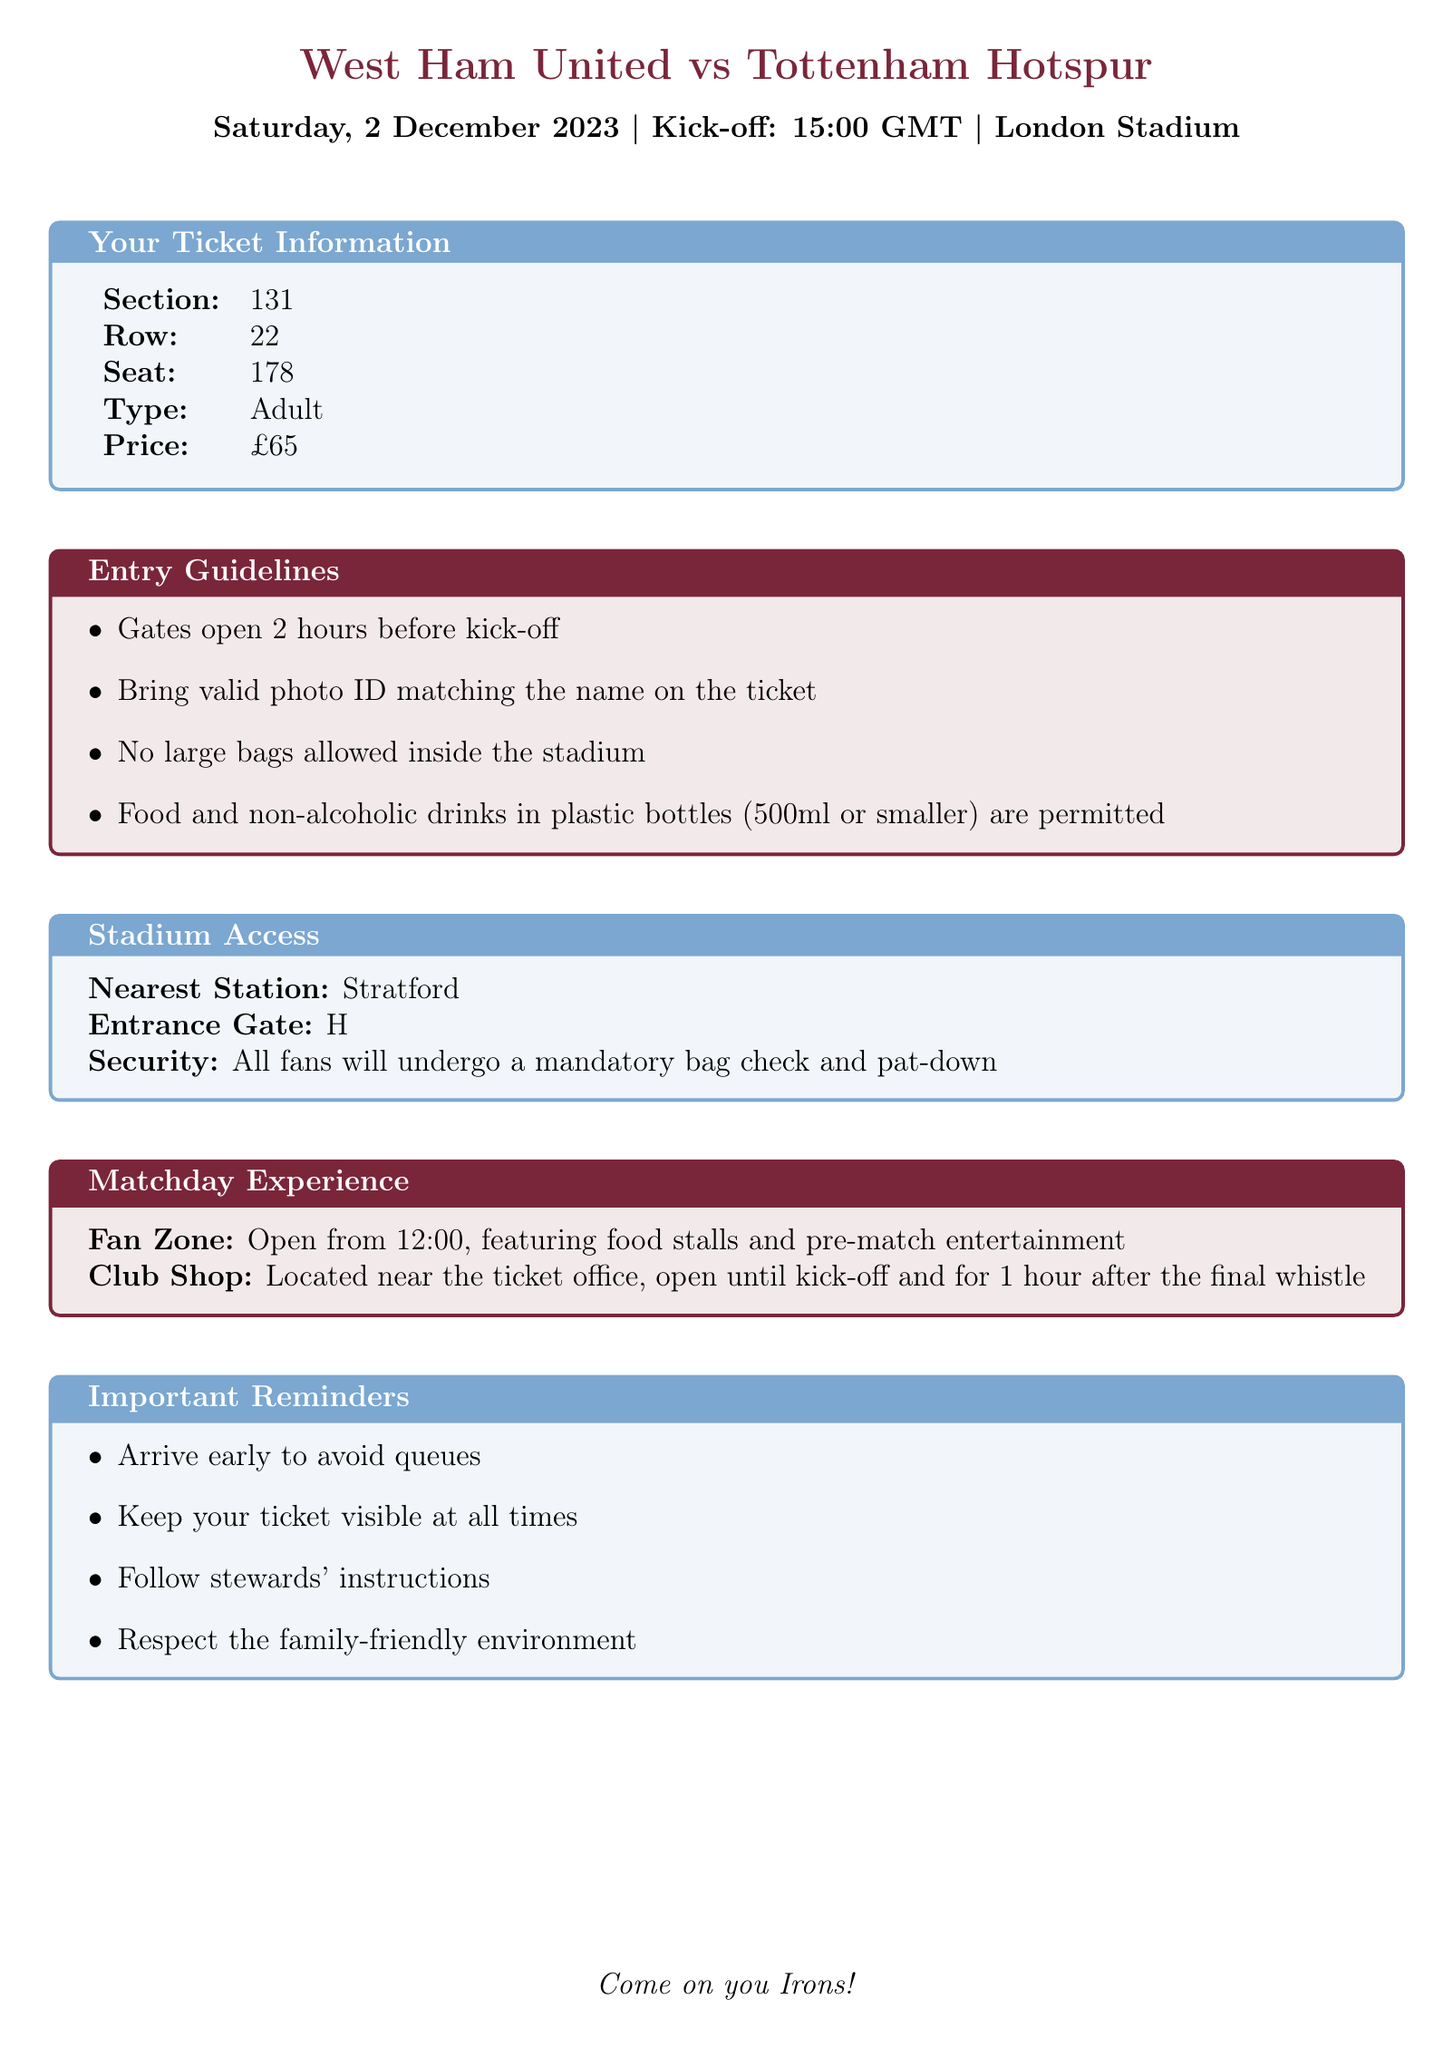What is the date of the match? The date of the match is mentioned in the match details section of the document.
Answer: Saturday, 2 December 2023 Which teams are playing in the match? The document specifies the home and away teams in the match details section.
Answer: West Ham United vs Tottenham Hotspur What is the seat number? The seat number is provided in the ticket information section of the document.
Answer: 178 What time do the gates open? The entry guidelines mention that the gates open 2 hours before kick-off.
Answer: 13:00 GMT What is the ticket price? The price of the ticket is stated in the ticket information section.
Answer: £65 Where is the nearest station? The nearest station is indicated in the stadium access section.
Answer: Stratford What is the entrance gate? The entrance gate is detailed in the stadium access section of the document.
Answer: H What should you bring for entry? Entry guidelines specify the requirement for identification.
Answer: Valid photo ID What time does the fan zone open? The matchday experience section states when the fan zone opens.
Answer: 12:00 What is one important reminder? The document lists several important reminders.
Answer: Arrive early to avoid queues 